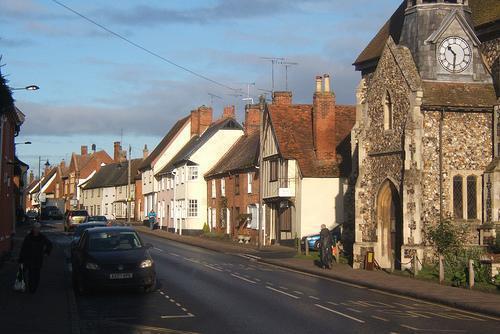What is the person on the left standing next to?
Choose the right answer and clarify with the format: 'Answer: answer
Rationale: rationale.'
Options: Airplane, car, baby, umbrella. Answer: car.
Rationale: The person is by a car. 